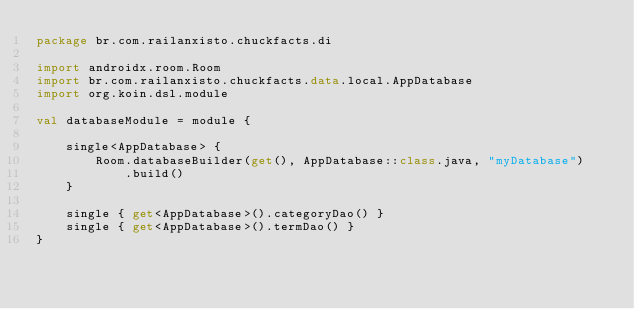Convert code to text. <code><loc_0><loc_0><loc_500><loc_500><_Kotlin_>package br.com.railanxisto.chuckfacts.di

import androidx.room.Room
import br.com.railanxisto.chuckfacts.data.local.AppDatabase
import org.koin.dsl.module

val databaseModule = module {

    single<AppDatabase> {
        Room.databaseBuilder(get(), AppDatabase::class.java, "myDatabase")
            .build()
    }

    single { get<AppDatabase>().categoryDao() }
    single { get<AppDatabase>().termDao() }
}</code> 